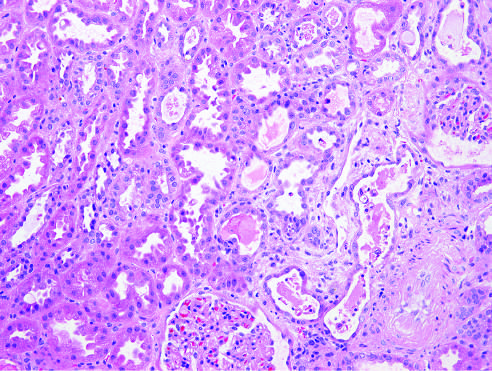does acute tubular epithelial cell injury with blebbing at the luminal pole, detachment of tubular cells from their underlying basement membranes, and granular cast?
Answer the question using a single word or phrase. Yes 